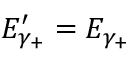Convert formula to latex. <formula><loc_0><loc_0><loc_500><loc_500>E _ { \gamma _ { + } } ^ { \prime } = E _ { \gamma _ { + } }</formula> 